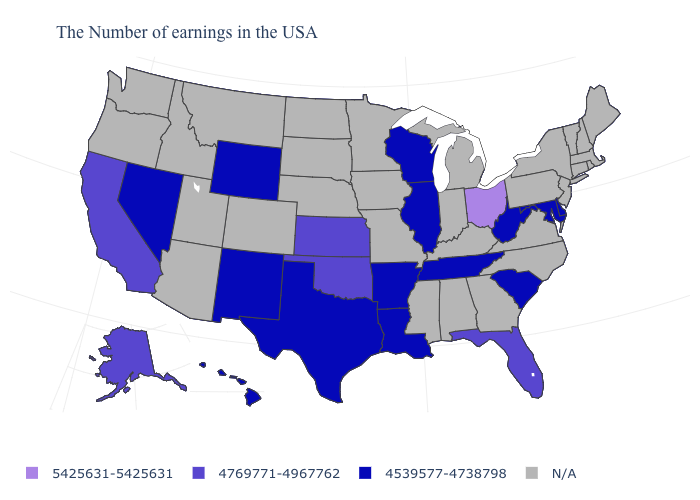What is the value of Tennessee?
Write a very short answer. 4539577-4738798. Is the legend a continuous bar?
Answer briefly. No. Which states have the highest value in the USA?
Short answer required. Ohio. What is the value of Nebraska?
Keep it brief. N/A. Does Ohio have the highest value in the MidWest?
Give a very brief answer. Yes. Among the states that border Iowa , which have the highest value?
Write a very short answer. Wisconsin, Illinois. What is the value of Arkansas?
Concise answer only. 4539577-4738798. What is the value of Louisiana?
Short answer required. 4539577-4738798. What is the highest value in states that border Alabama?
Give a very brief answer. 4769771-4967762. Name the states that have a value in the range 4539577-4738798?
Write a very short answer. Delaware, Maryland, South Carolina, West Virginia, Tennessee, Wisconsin, Illinois, Louisiana, Arkansas, Texas, Wyoming, New Mexico, Nevada, Hawaii. What is the value of Hawaii?
Keep it brief. 4539577-4738798. Name the states that have a value in the range 4539577-4738798?
Concise answer only. Delaware, Maryland, South Carolina, West Virginia, Tennessee, Wisconsin, Illinois, Louisiana, Arkansas, Texas, Wyoming, New Mexico, Nevada, Hawaii. What is the value of Idaho?
Be succinct. N/A. 